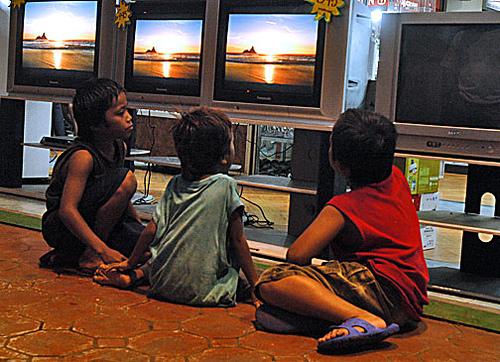How many boys are there?
Keep it brief. 3. How many TVs are in?
Quick response, please. 3. Is this a residential scene?
Short answer required. No. 